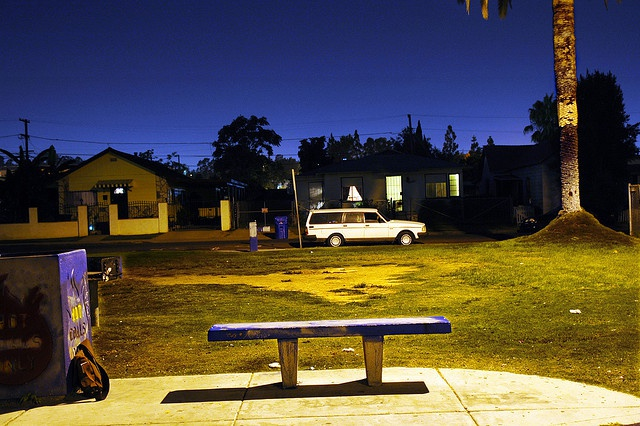Describe the objects in this image and their specific colors. I can see bench in navy, black, lightgray, olive, and maroon tones, car in navy, ivory, black, khaki, and maroon tones, and backpack in navy, black, brown, maroon, and olive tones in this image. 